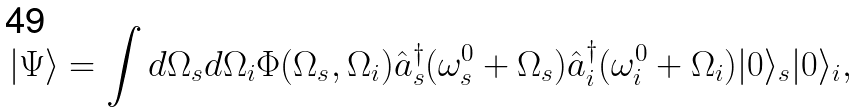<formula> <loc_0><loc_0><loc_500><loc_500>| \Psi \rangle = \int d \Omega _ { s } d \Omega _ { i } \Phi ( \Omega _ { s } , \Omega _ { i } ) \hat { a } _ { s } ^ { \dagger } ( \omega _ { s } ^ { 0 } + \Omega _ { s } ) \hat { a } _ { i } ^ { \dagger } ( \omega _ { i } ^ { 0 } + \Omega _ { i } ) | 0 \rangle _ { s } | 0 \rangle _ { i } ,</formula> 